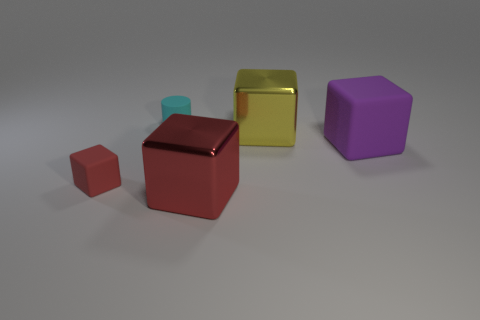Subtract 1 cubes. How many cubes are left? 3 Subtract all big rubber blocks. How many blocks are left? 3 Subtract all yellow blocks. How many blocks are left? 3 Subtract all cyan blocks. Subtract all red cylinders. How many blocks are left? 4 Add 4 cylinders. How many objects exist? 9 Subtract all cylinders. How many objects are left? 4 Subtract all big gray matte cubes. Subtract all large matte things. How many objects are left? 4 Add 5 big cubes. How many big cubes are left? 8 Add 3 red objects. How many red objects exist? 5 Subtract 0 green blocks. How many objects are left? 5 